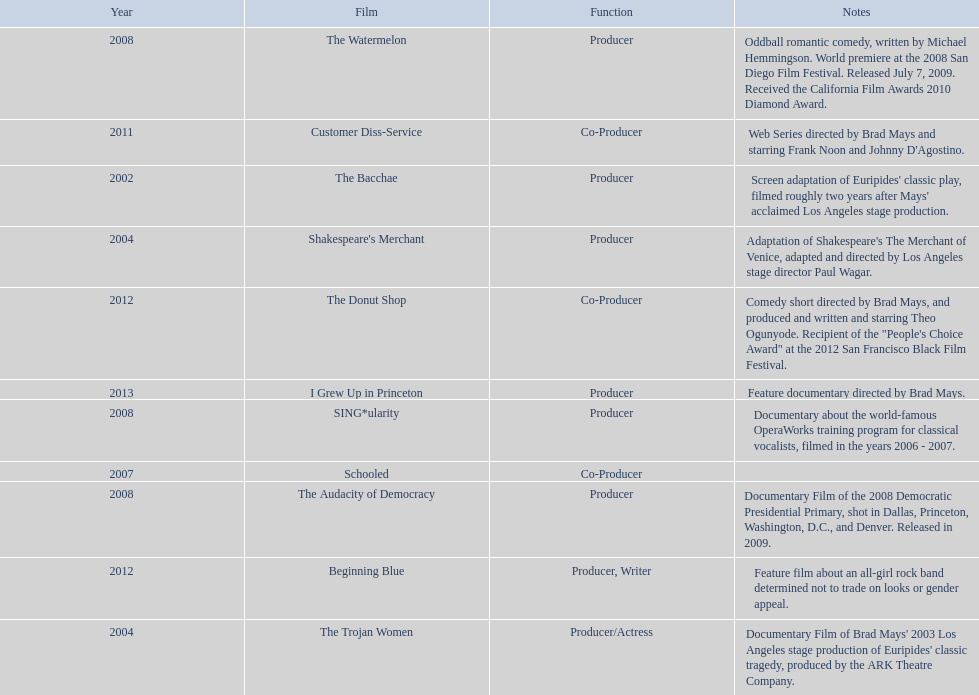How many years before was the film bacchae out before the watermelon? 6. 